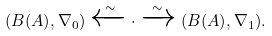Convert formula to latex. <formula><loc_0><loc_0><loc_500><loc_500>( B ( A ) , \nabla _ { 0 } ) \xleftarrow { \sim } \cdot \xrightarrow { \sim } ( B ( A ) , \nabla _ { 1 } ) .</formula> 